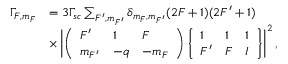Convert formula to latex. <formula><loc_0><loc_0><loc_500><loc_500>\begin{array} { r } { \begin{array} { r l } { \Gamma _ { F , m _ { F } } } & { = 3 \Gamma _ { s c } \sum _ { F ^ { \prime } , m _ { F ^ { \prime } } } \delta _ { m _ { F } , m _ { F ^ { \prime } } } ( 2 F + 1 ) ( 2 F ^ { \prime } + 1 ) } \\ & { \times \left | \left ( \begin{array} { l l l } { F ^ { \prime } } & { 1 } & { F } \\ { m _ { F ^ { \prime } } } & { - q } & { - m _ { F } } \end{array} \right ) \left \{ \begin{array} { l l l } { 1 } & { 1 } & { 1 } \\ { F ^ { \prime } } & { F } & { I } \end{array} \right \} \right | ^ { 2 } , } \end{array} } \end{array}</formula> 